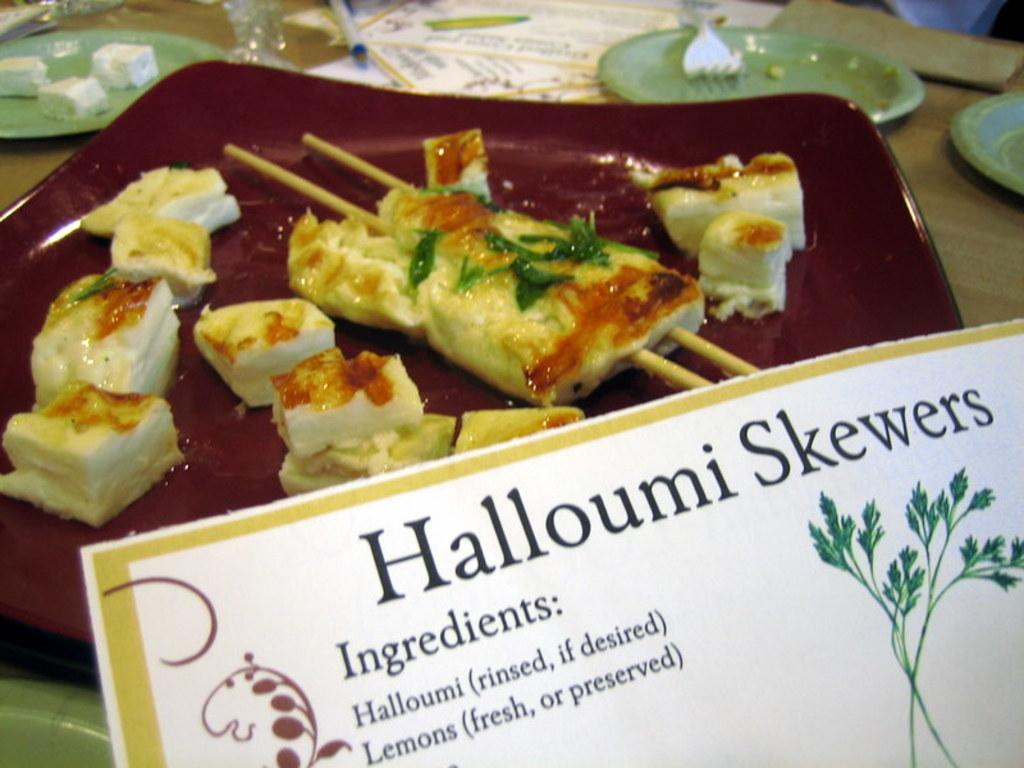What is depicted on the poster in the image? There is a poster with text in the image. What can be seen on the plate in the image? There is a plate with food items in the image. How many other plates are visible in the image? There are other plates in the image. What type of container is present in the image? There is a glass in the image. What utensil is visible in the image? There is a fork in the image. What type of surface is present in the image? The wooden surface is present in the image. What type of behavior does the rainstorm exhibit in the image? There is no rainstorm present in the image; it only features a poster, plates, a glass, a fork, and a wooden surface. What flavor of food is depicted on the plate in the image? The provided facts do not mention the flavor of the food on the plate, only that there are food items present. 